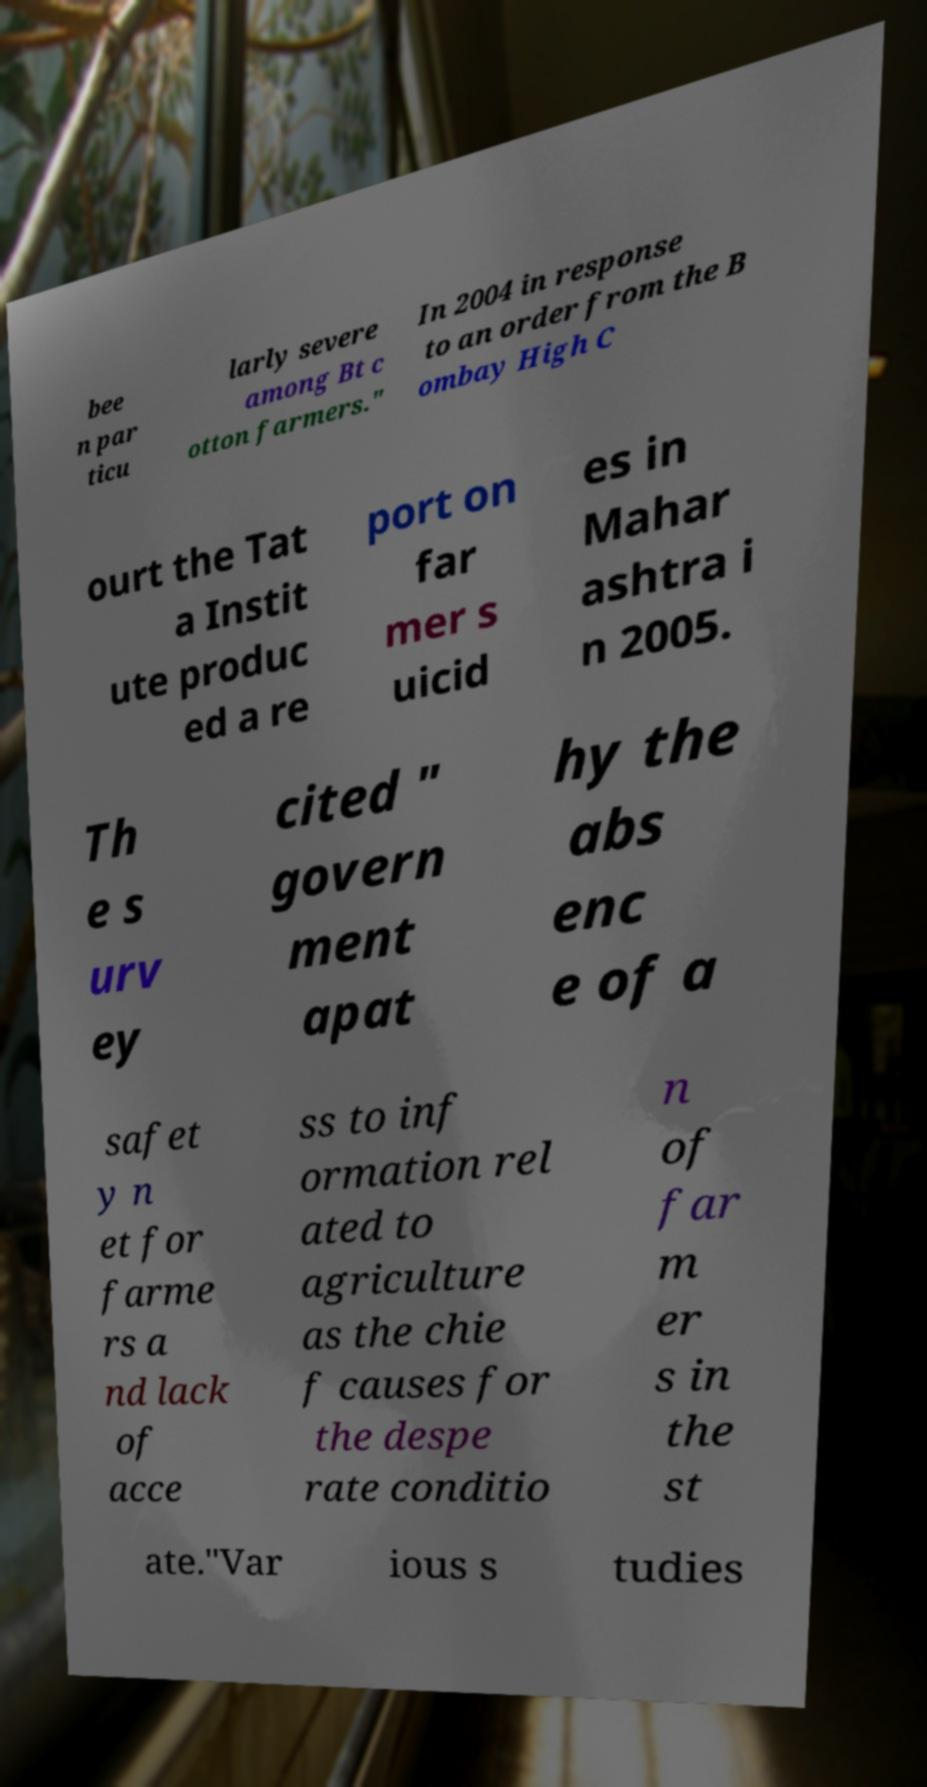Can you accurately transcribe the text from the provided image for me? bee n par ticu larly severe among Bt c otton farmers." In 2004 in response to an order from the B ombay High C ourt the Tat a Instit ute produc ed a re port on far mer s uicid es in Mahar ashtra i n 2005. Th e s urv ey cited " govern ment apat hy the abs enc e of a safet y n et for farme rs a nd lack of acce ss to inf ormation rel ated to agriculture as the chie f causes for the despe rate conditio n of far m er s in the st ate."Var ious s tudies 